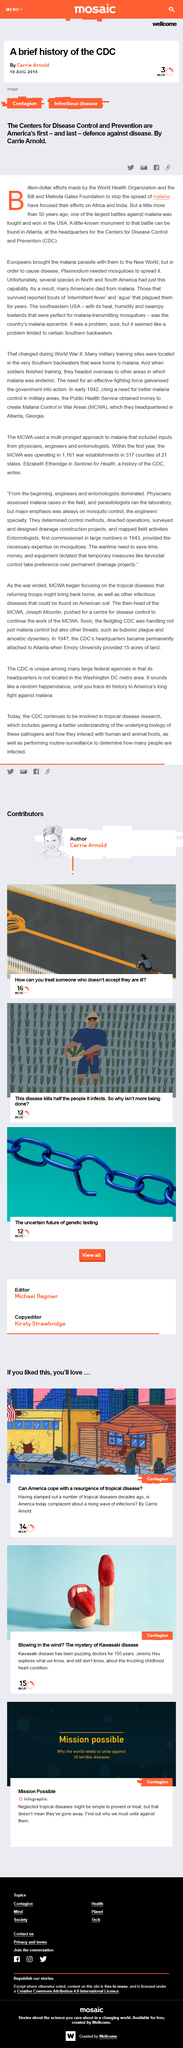Point out several critical features in this image. This paper provides a concise history of the CDC, which is the focus of its concern. The page was published on 10th August 2015. The page was authored by Carrie Arnold. 